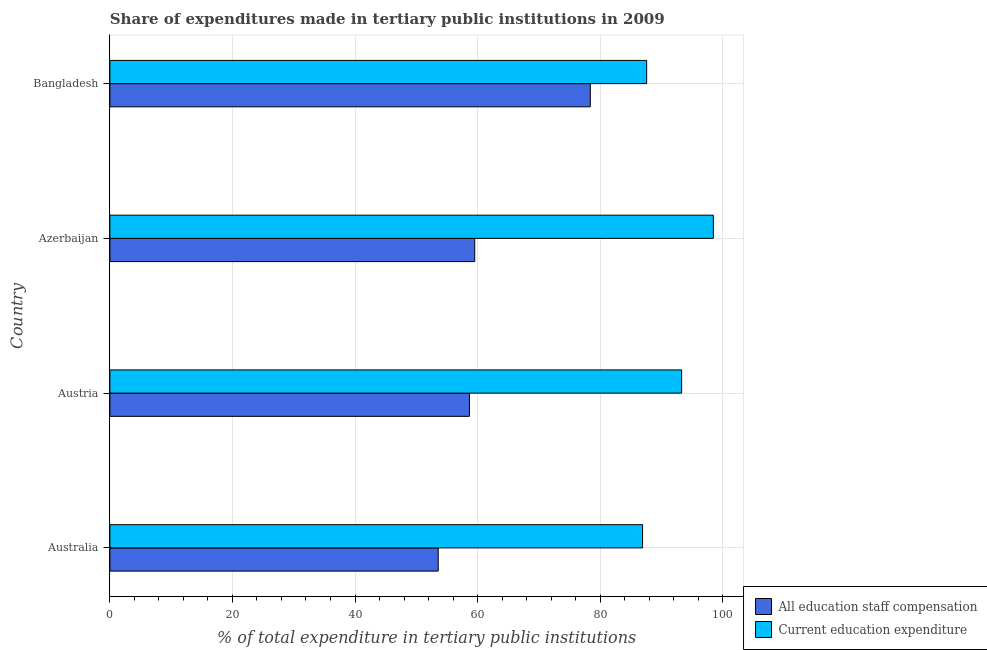Are the number of bars on each tick of the Y-axis equal?
Give a very brief answer. Yes. How many bars are there on the 4th tick from the top?
Your answer should be compact. 2. How many bars are there on the 1st tick from the bottom?
Offer a terse response. 2. What is the label of the 2nd group of bars from the top?
Your answer should be very brief. Azerbaijan. In how many cases, is the number of bars for a given country not equal to the number of legend labels?
Keep it short and to the point. 0. What is the expenditure in staff compensation in Azerbaijan?
Provide a succinct answer. 59.54. Across all countries, what is the maximum expenditure in staff compensation?
Make the answer very short. 78.4. Across all countries, what is the minimum expenditure in education?
Give a very brief answer. 86.93. In which country was the expenditure in education maximum?
Your answer should be compact. Azerbaijan. What is the total expenditure in education in the graph?
Make the answer very short. 366.3. What is the difference between the expenditure in education in Australia and that in Austria?
Your response must be concise. -6.37. What is the difference between the expenditure in education in Austria and the expenditure in staff compensation in Azerbaijan?
Provide a succinct answer. 33.77. What is the average expenditure in education per country?
Your answer should be very brief. 91.58. What is the difference between the expenditure in education and expenditure in staff compensation in Australia?
Make the answer very short. 33.35. In how many countries, is the expenditure in education greater than 16 %?
Offer a terse response. 4. What is the ratio of the expenditure in education in Australia to that in Bangladesh?
Keep it short and to the point. 0.99. What is the difference between the highest and the second highest expenditure in education?
Your response must be concise. 5.17. What is the difference between the highest and the lowest expenditure in staff compensation?
Provide a short and direct response. 24.82. In how many countries, is the expenditure in staff compensation greater than the average expenditure in staff compensation taken over all countries?
Make the answer very short. 1. Is the sum of the expenditure in education in Australia and Austria greater than the maximum expenditure in staff compensation across all countries?
Offer a terse response. Yes. What does the 1st bar from the top in Australia represents?
Provide a short and direct response. Current education expenditure. What does the 2nd bar from the bottom in Bangladesh represents?
Your response must be concise. Current education expenditure. How many bars are there?
Offer a very short reply. 8. Are all the bars in the graph horizontal?
Give a very brief answer. Yes. What is the difference between two consecutive major ticks on the X-axis?
Ensure brevity in your answer.  20. Does the graph contain any zero values?
Provide a succinct answer. No. How many legend labels are there?
Provide a succinct answer. 2. How are the legend labels stacked?
Ensure brevity in your answer.  Vertical. What is the title of the graph?
Offer a terse response. Share of expenditures made in tertiary public institutions in 2009. Does "DAC donors" appear as one of the legend labels in the graph?
Make the answer very short. No. What is the label or title of the X-axis?
Provide a succinct answer. % of total expenditure in tertiary public institutions. What is the % of total expenditure in tertiary public institutions in All education staff compensation in Australia?
Keep it short and to the point. 53.58. What is the % of total expenditure in tertiary public institutions in Current education expenditure in Australia?
Your answer should be compact. 86.93. What is the % of total expenditure in tertiary public institutions of All education staff compensation in Austria?
Offer a very short reply. 58.68. What is the % of total expenditure in tertiary public institutions in Current education expenditure in Austria?
Offer a terse response. 93.3. What is the % of total expenditure in tertiary public institutions in All education staff compensation in Azerbaijan?
Provide a succinct answer. 59.54. What is the % of total expenditure in tertiary public institutions of Current education expenditure in Azerbaijan?
Ensure brevity in your answer.  98.48. What is the % of total expenditure in tertiary public institutions of All education staff compensation in Bangladesh?
Your answer should be very brief. 78.4. What is the % of total expenditure in tertiary public institutions of Current education expenditure in Bangladesh?
Your response must be concise. 87.59. Across all countries, what is the maximum % of total expenditure in tertiary public institutions in All education staff compensation?
Give a very brief answer. 78.4. Across all countries, what is the maximum % of total expenditure in tertiary public institutions of Current education expenditure?
Offer a very short reply. 98.48. Across all countries, what is the minimum % of total expenditure in tertiary public institutions of All education staff compensation?
Your answer should be compact. 53.58. Across all countries, what is the minimum % of total expenditure in tertiary public institutions of Current education expenditure?
Provide a short and direct response. 86.93. What is the total % of total expenditure in tertiary public institutions of All education staff compensation in the graph?
Provide a short and direct response. 250.19. What is the total % of total expenditure in tertiary public institutions in Current education expenditure in the graph?
Keep it short and to the point. 366.3. What is the difference between the % of total expenditure in tertiary public institutions of All education staff compensation in Australia and that in Austria?
Provide a succinct answer. -5.1. What is the difference between the % of total expenditure in tertiary public institutions in Current education expenditure in Australia and that in Austria?
Offer a very short reply. -6.37. What is the difference between the % of total expenditure in tertiary public institutions of All education staff compensation in Australia and that in Azerbaijan?
Your answer should be compact. -5.96. What is the difference between the % of total expenditure in tertiary public institutions in Current education expenditure in Australia and that in Azerbaijan?
Offer a terse response. -11.55. What is the difference between the % of total expenditure in tertiary public institutions in All education staff compensation in Australia and that in Bangladesh?
Ensure brevity in your answer.  -24.82. What is the difference between the % of total expenditure in tertiary public institutions in Current education expenditure in Australia and that in Bangladesh?
Provide a short and direct response. -0.66. What is the difference between the % of total expenditure in tertiary public institutions in All education staff compensation in Austria and that in Azerbaijan?
Offer a very short reply. -0.86. What is the difference between the % of total expenditure in tertiary public institutions in Current education expenditure in Austria and that in Azerbaijan?
Your answer should be compact. -5.17. What is the difference between the % of total expenditure in tertiary public institutions of All education staff compensation in Austria and that in Bangladesh?
Your response must be concise. -19.72. What is the difference between the % of total expenditure in tertiary public institutions of Current education expenditure in Austria and that in Bangladesh?
Make the answer very short. 5.71. What is the difference between the % of total expenditure in tertiary public institutions of All education staff compensation in Azerbaijan and that in Bangladesh?
Your response must be concise. -18.86. What is the difference between the % of total expenditure in tertiary public institutions in Current education expenditure in Azerbaijan and that in Bangladesh?
Give a very brief answer. 10.88. What is the difference between the % of total expenditure in tertiary public institutions of All education staff compensation in Australia and the % of total expenditure in tertiary public institutions of Current education expenditure in Austria?
Give a very brief answer. -39.72. What is the difference between the % of total expenditure in tertiary public institutions of All education staff compensation in Australia and the % of total expenditure in tertiary public institutions of Current education expenditure in Azerbaijan?
Your answer should be compact. -44.9. What is the difference between the % of total expenditure in tertiary public institutions of All education staff compensation in Australia and the % of total expenditure in tertiary public institutions of Current education expenditure in Bangladesh?
Keep it short and to the point. -34.01. What is the difference between the % of total expenditure in tertiary public institutions of All education staff compensation in Austria and the % of total expenditure in tertiary public institutions of Current education expenditure in Azerbaijan?
Keep it short and to the point. -39.8. What is the difference between the % of total expenditure in tertiary public institutions of All education staff compensation in Austria and the % of total expenditure in tertiary public institutions of Current education expenditure in Bangladesh?
Your response must be concise. -28.92. What is the difference between the % of total expenditure in tertiary public institutions of All education staff compensation in Azerbaijan and the % of total expenditure in tertiary public institutions of Current education expenditure in Bangladesh?
Offer a terse response. -28.06. What is the average % of total expenditure in tertiary public institutions of All education staff compensation per country?
Your answer should be very brief. 62.55. What is the average % of total expenditure in tertiary public institutions in Current education expenditure per country?
Provide a succinct answer. 91.58. What is the difference between the % of total expenditure in tertiary public institutions of All education staff compensation and % of total expenditure in tertiary public institutions of Current education expenditure in Australia?
Offer a terse response. -33.35. What is the difference between the % of total expenditure in tertiary public institutions in All education staff compensation and % of total expenditure in tertiary public institutions in Current education expenditure in Austria?
Keep it short and to the point. -34.63. What is the difference between the % of total expenditure in tertiary public institutions in All education staff compensation and % of total expenditure in tertiary public institutions in Current education expenditure in Azerbaijan?
Give a very brief answer. -38.94. What is the difference between the % of total expenditure in tertiary public institutions in All education staff compensation and % of total expenditure in tertiary public institutions in Current education expenditure in Bangladesh?
Your response must be concise. -9.2. What is the ratio of the % of total expenditure in tertiary public institutions of All education staff compensation in Australia to that in Austria?
Provide a short and direct response. 0.91. What is the ratio of the % of total expenditure in tertiary public institutions of Current education expenditure in Australia to that in Austria?
Make the answer very short. 0.93. What is the ratio of the % of total expenditure in tertiary public institutions of All education staff compensation in Australia to that in Azerbaijan?
Provide a succinct answer. 0.9. What is the ratio of the % of total expenditure in tertiary public institutions in Current education expenditure in Australia to that in Azerbaijan?
Your response must be concise. 0.88. What is the ratio of the % of total expenditure in tertiary public institutions of All education staff compensation in Australia to that in Bangladesh?
Keep it short and to the point. 0.68. What is the ratio of the % of total expenditure in tertiary public institutions in Current education expenditure in Australia to that in Bangladesh?
Make the answer very short. 0.99. What is the ratio of the % of total expenditure in tertiary public institutions in All education staff compensation in Austria to that in Azerbaijan?
Your answer should be compact. 0.99. What is the ratio of the % of total expenditure in tertiary public institutions of Current education expenditure in Austria to that in Azerbaijan?
Provide a short and direct response. 0.95. What is the ratio of the % of total expenditure in tertiary public institutions of All education staff compensation in Austria to that in Bangladesh?
Keep it short and to the point. 0.75. What is the ratio of the % of total expenditure in tertiary public institutions of Current education expenditure in Austria to that in Bangladesh?
Your answer should be very brief. 1.07. What is the ratio of the % of total expenditure in tertiary public institutions in All education staff compensation in Azerbaijan to that in Bangladesh?
Your response must be concise. 0.76. What is the ratio of the % of total expenditure in tertiary public institutions of Current education expenditure in Azerbaijan to that in Bangladesh?
Your answer should be compact. 1.12. What is the difference between the highest and the second highest % of total expenditure in tertiary public institutions in All education staff compensation?
Your response must be concise. 18.86. What is the difference between the highest and the second highest % of total expenditure in tertiary public institutions in Current education expenditure?
Offer a terse response. 5.17. What is the difference between the highest and the lowest % of total expenditure in tertiary public institutions of All education staff compensation?
Offer a very short reply. 24.82. What is the difference between the highest and the lowest % of total expenditure in tertiary public institutions of Current education expenditure?
Your answer should be very brief. 11.55. 